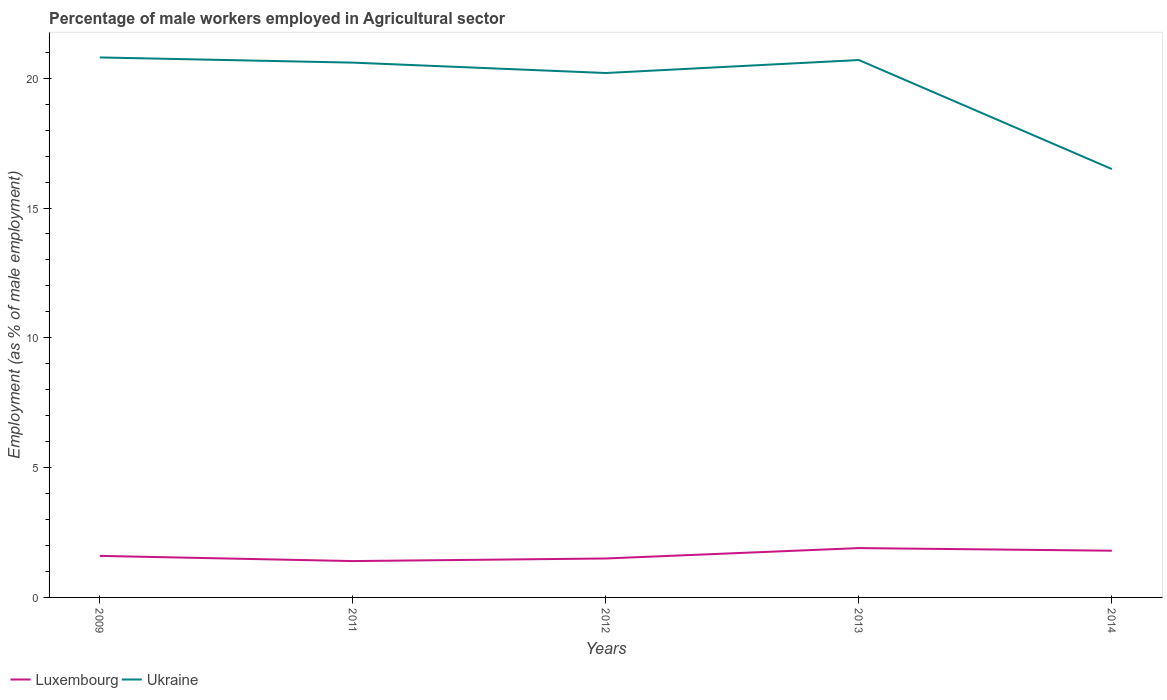Across all years, what is the maximum percentage of male workers employed in Agricultural sector in Luxembourg?
Make the answer very short. 1.4. In which year was the percentage of male workers employed in Agricultural sector in Luxembourg maximum?
Make the answer very short. 2011. What is the total percentage of male workers employed in Agricultural sector in Ukraine in the graph?
Provide a succinct answer. -0.1. What is the difference between the highest and the second highest percentage of male workers employed in Agricultural sector in Ukraine?
Your response must be concise. 4.3. How many lines are there?
Your response must be concise. 2. Where does the legend appear in the graph?
Your answer should be very brief. Bottom left. What is the title of the graph?
Your answer should be compact. Percentage of male workers employed in Agricultural sector. Does "Libya" appear as one of the legend labels in the graph?
Make the answer very short. No. What is the label or title of the X-axis?
Your answer should be compact. Years. What is the label or title of the Y-axis?
Your answer should be very brief. Employment (as % of male employment). What is the Employment (as % of male employment) of Luxembourg in 2009?
Offer a terse response. 1.6. What is the Employment (as % of male employment) of Ukraine in 2009?
Keep it short and to the point. 20.8. What is the Employment (as % of male employment) of Luxembourg in 2011?
Make the answer very short. 1.4. What is the Employment (as % of male employment) in Ukraine in 2011?
Offer a very short reply. 20.6. What is the Employment (as % of male employment) in Ukraine in 2012?
Your response must be concise. 20.2. What is the Employment (as % of male employment) of Luxembourg in 2013?
Your answer should be compact. 1.9. What is the Employment (as % of male employment) of Ukraine in 2013?
Provide a short and direct response. 20.7. What is the Employment (as % of male employment) in Luxembourg in 2014?
Provide a short and direct response. 1.8. What is the Employment (as % of male employment) of Ukraine in 2014?
Provide a succinct answer. 16.5. Across all years, what is the maximum Employment (as % of male employment) of Luxembourg?
Your answer should be compact. 1.9. Across all years, what is the maximum Employment (as % of male employment) of Ukraine?
Offer a very short reply. 20.8. Across all years, what is the minimum Employment (as % of male employment) in Luxembourg?
Your answer should be very brief. 1.4. Across all years, what is the minimum Employment (as % of male employment) of Ukraine?
Provide a succinct answer. 16.5. What is the total Employment (as % of male employment) in Luxembourg in the graph?
Offer a terse response. 8.2. What is the total Employment (as % of male employment) of Ukraine in the graph?
Your answer should be very brief. 98.8. What is the difference between the Employment (as % of male employment) in Luxembourg in 2009 and that in 2011?
Your response must be concise. 0.2. What is the difference between the Employment (as % of male employment) in Luxembourg in 2009 and that in 2012?
Offer a terse response. 0.1. What is the difference between the Employment (as % of male employment) in Ukraine in 2009 and that in 2012?
Offer a very short reply. 0.6. What is the difference between the Employment (as % of male employment) of Ukraine in 2011 and that in 2013?
Provide a short and direct response. -0.1. What is the difference between the Employment (as % of male employment) of Luxembourg in 2011 and that in 2014?
Provide a succinct answer. -0.4. What is the difference between the Employment (as % of male employment) in Luxembourg in 2012 and that in 2013?
Your answer should be compact. -0.4. What is the difference between the Employment (as % of male employment) in Ukraine in 2012 and that in 2013?
Provide a succinct answer. -0.5. What is the difference between the Employment (as % of male employment) of Ukraine in 2012 and that in 2014?
Give a very brief answer. 3.7. What is the difference between the Employment (as % of male employment) of Ukraine in 2013 and that in 2014?
Give a very brief answer. 4.2. What is the difference between the Employment (as % of male employment) of Luxembourg in 2009 and the Employment (as % of male employment) of Ukraine in 2011?
Provide a succinct answer. -19. What is the difference between the Employment (as % of male employment) of Luxembourg in 2009 and the Employment (as % of male employment) of Ukraine in 2012?
Ensure brevity in your answer.  -18.6. What is the difference between the Employment (as % of male employment) in Luxembourg in 2009 and the Employment (as % of male employment) in Ukraine in 2013?
Your answer should be compact. -19.1. What is the difference between the Employment (as % of male employment) in Luxembourg in 2009 and the Employment (as % of male employment) in Ukraine in 2014?
Keep it short and to the point. -14.9. What is the difference between the Employment (as % of male employment) of Luxembourg in 2011 and the Employment (as % of male employment) of Ukraine in 2012?
Offer a terse response. -18.8. What is the difference between the Employment (as % of male employment) in Luxembourg in 2011 and the Employment (as % of male employment) in Ukraine in 2013?
Give a very brief answer. -19.3. What is the difference between the Employment (as % of male employment) in Luxembourg in 2011 and the Employment (as % of male employment) in Ukraine in 2014?
Provide a short and direct response. -15.1. What is the difference between the Employment (as % of male employment) of Luxembourg in 2012 and the Employment (as % of male employment) of Ukraine in 2013?
Give a very brief answer. -19.2. What is the difference between the Employment (as % of male employment) in Luxembourg in 2012 and the Employment (as % of male employment) in Ukraine in 2014?
Your answer should be very brief. -15. What is the difference between the Employment (as % of male employment) in Luxembourg in 2013 and the Employment (as % of male employment) in Ukraine in 2014?
Offer a very short reply. -14.6. What is the average Employment (as % of male employment) of Luxembourg per year?
Make the answer very short. 1.64. What is the average Employment (as % of male employment) of Ukraine per year?
Offer a terse response. 19.76. In the year 2009, what is the difference between the Employment (as % of male employment) in Luxembourg and Employment (as % of male employment) in Ukraine?
Offer a terse response. -19.2. In the year 2011, what is the difference between the Employment (as % of male employment) of Luxembourg and Employment (as % of male employment) of Ukraine?
Keep it short and to the point. -19.2. In the year 2012, what is the difference between the Employment (as % of male employment) of Luxembourg and Employment (as % of male employment) of Ukraine?
Your response must be concise. -18.7. In the year 2013, what is the difference between the Employment (as % of male employment) in Luxembourg and Employment (as % of male employment) in Ukraine?
Provide a short and direct response. -18.8. In the year 2014, what is the difference between the Employment (as % of male employment) in Luxembourg and Employment (as % of male employment) in Ukraine?
Your response must be concise. -14.7. What is the ratio of the Employment (as % of male employment) of Ukraine in 2009 to that in 2011?
Make the answer very short. 1.01. What is the ratio of the Employment (as % of male employment) in Luxembourg in 2009 to that in 2012?
Your answer should be compact. 1.07. What is the ratio of the Employment (as % of male employment) in Ukraine in 2009 to that in 2012?
Give a very brief answer. 1.03. What is the ratio of the Employment (as % of male employment) of Luxembourg in 2009 to that in 2013?
Provide a succinct answer. 0.84. What is the ratio of the Employment (as % of male employment) of Luxembourg in 2009 to that in 2014?
Make the answer very short. 0.89. What is the ratio of the Employment (as % of male employment) in Ukraine in 2009 to that in 2014?
Give a very brief answer. 1.26. What is the ratio of the Employment (as % of male employment) in Luxembourg in 2011 to that in 2012?
Your answer should be compact. 0.93. What is the ratio of the Employment (as % of male employment) in Ukraine in 2011 to that in 2012?
Your answer should be compact. 1.02. What is the ratio of the Employment (as % of male employment) in Luxembourg in 2011 to that in 2013?
Your response must be concise. 0.74. What is the ratio of the Employment (as % of male employment) in Ukraine in 2011 to that in 2013?
Offer a very short reply. 1. What is the ratio of the Employment (as % of male employment) of Ukraine in 2011 to that in 2014?
Provide a short and direct response. 1.25. What is the ratio of the Employment (as % of male employment) of Luxembourg in 2012 to that in 2013?
Give a very brief answer. 0.79. What is the ratio of the Employment (as % of male employment) of Ukraine in 2012 to that in 2013?
Provide a short and direct response. 0.98. What is the ratio of the Employment (as % of male employment) in Ukraine in 2012 to that in 2014?
Your answer should be compact. 1.22. What is the ratio of the Employment (as % of male employment) of Luxembourg in 2013 to that in 2014?
Offer a terse response. 1.06. What is the ratio of the Employment (as % of male employment) in Ukraine in 2013 to that in 2014?
Keep it short and to the point. 1.25. What is the difference between the highest and the second highest Employment (as % of male employment) of Luxembourg?
Offer a very short reply. 0.1. 